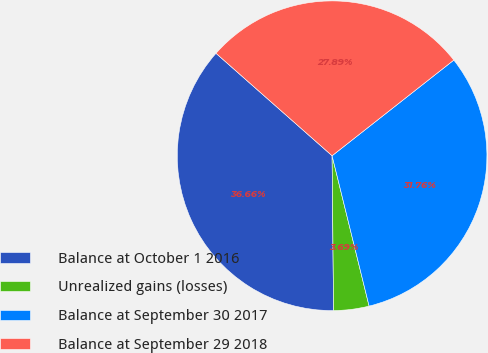Convert chart. <chart><loc_0><loc_0><loc_500><loc_500><pie_chart><fcel>Balance at October 1 2016<fcel>Unrealized gains (losses)<fcel>Balance at September 30 2017<fcel>Balance at September 29 2018<nl><fcel>36.66%<fcel>3.69%<fcel>31.76%<fcel>27.89%<nl></chart> 